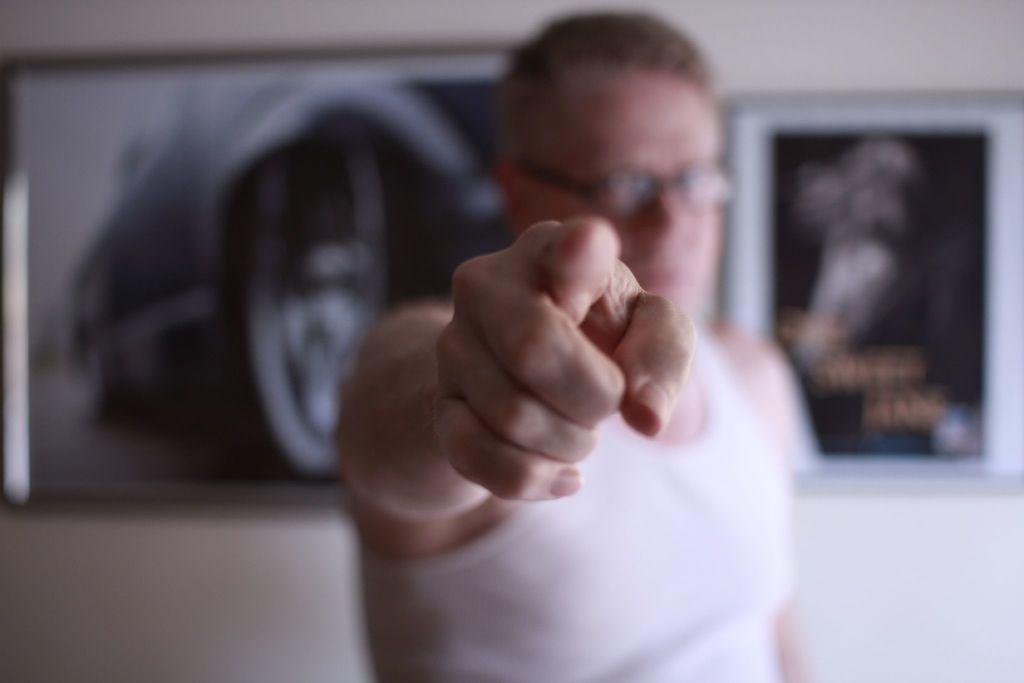Who or what is the main subject in the center of the image? There is a person in the center of the image. What is the person doing in the image? The person appears to be standing. What can be seen on the wall in the background of the image? There are picture frames hanging on the wall in the background. How would you describe the overall clarity of the image? The background of the image is blurry. What type of bait is the person using on the stage in the image? There is no bait or stage present in the image; it features a person standing in the center with a blurry background. What kind of cloth is draped over the person's shoulders in the image? There is no cloth draped over the person's shoulders in the image; they are simply standing with no additional clothing or accessories visible. 